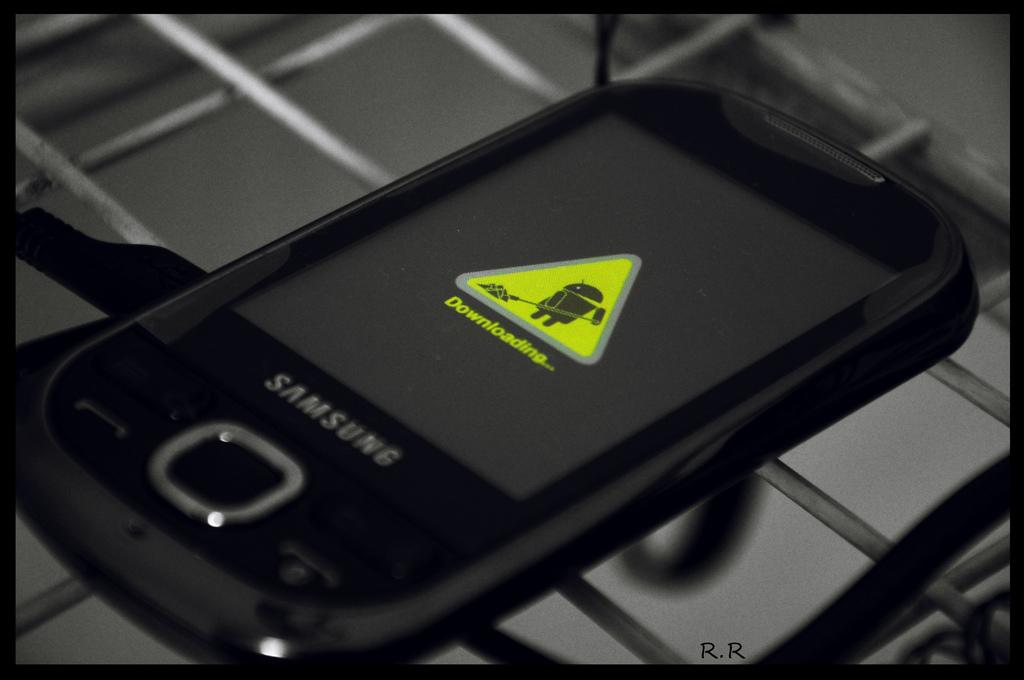<image>
Summarize the visual content of the image. A Samsung phone shows a downloading icon on the screen. 